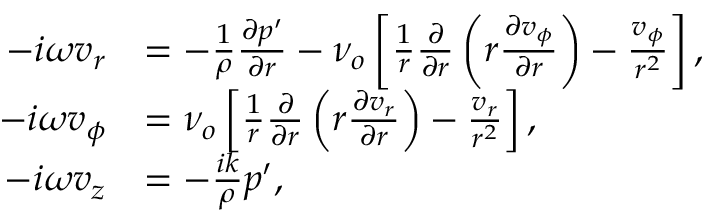Convert formula to latex. <formula><loc_0><loc_0><loc_500><loc_500>\begin{array} { r l } { - i \omega v _ { r } } & { = - \frac { 1 } { \rho } \frac { \partial p ^ { \prime } } { \partial r } - \nu _ { o } \left [ \frac { 1 } { r } \frac { \partial } { \partial r } \left ( r \frac { \partial v _ { \phi } } { \partial r } \right ) - \frac { v _ { \phi } } { r ^ { 2 } } \right ] , } \\ { - i \omega v _ { \phi } } & { = \nu _ { o } \left [ \frac { 1 } { r } \frac { \partial } { \partial r } \left ( r \frac { \partial v _ { r } } { \partial r } \right ) - \frac { v _ { r } } { r ^ { 2 } } \right ] , } \\ { - i \omega v _ { z } } & { = - \frac { i k } { \rho } p ^ { \prime } , } \end{array}</formula> 